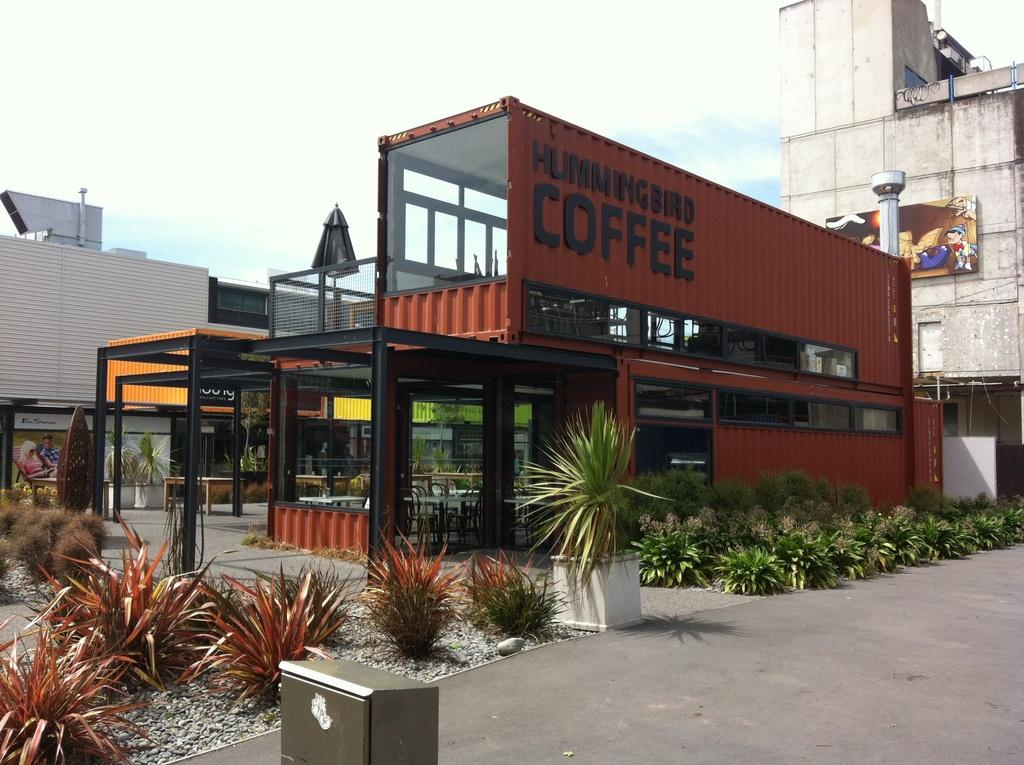What type of establishment is featured in the image? There is a hummingbird coffee shop in the image. Are there any other buildings visible in the image? Yes, there is a building beside the coffee shop and a building behind the coffee shop. How many elbows can be seen in the image? There are no elbows visible in the image, as it features a coffee shop and surrounding buildings. 